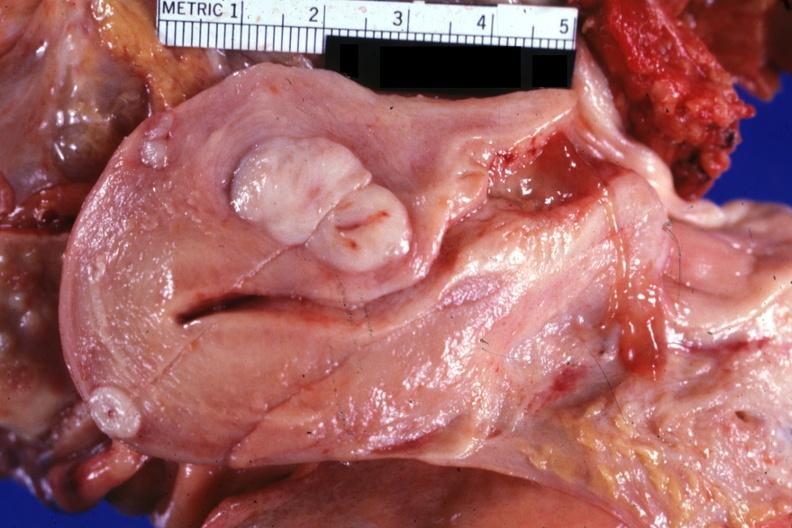s leiomyoma present?
Answer the question using a single word or phrase. Yes 